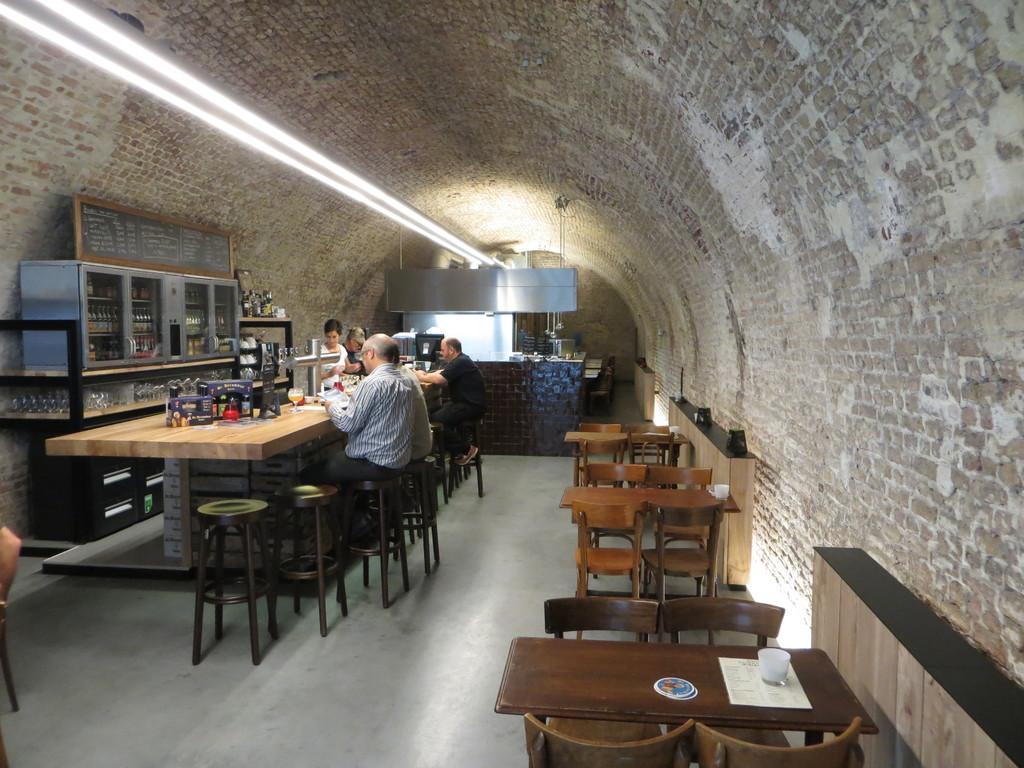Can you describe this image briefly? In this image i can see few people sitting on chairs in front of a table and few people standing, On the table i can see various objects. In the background i can see a light, a wall, few chairs and few bottles. 